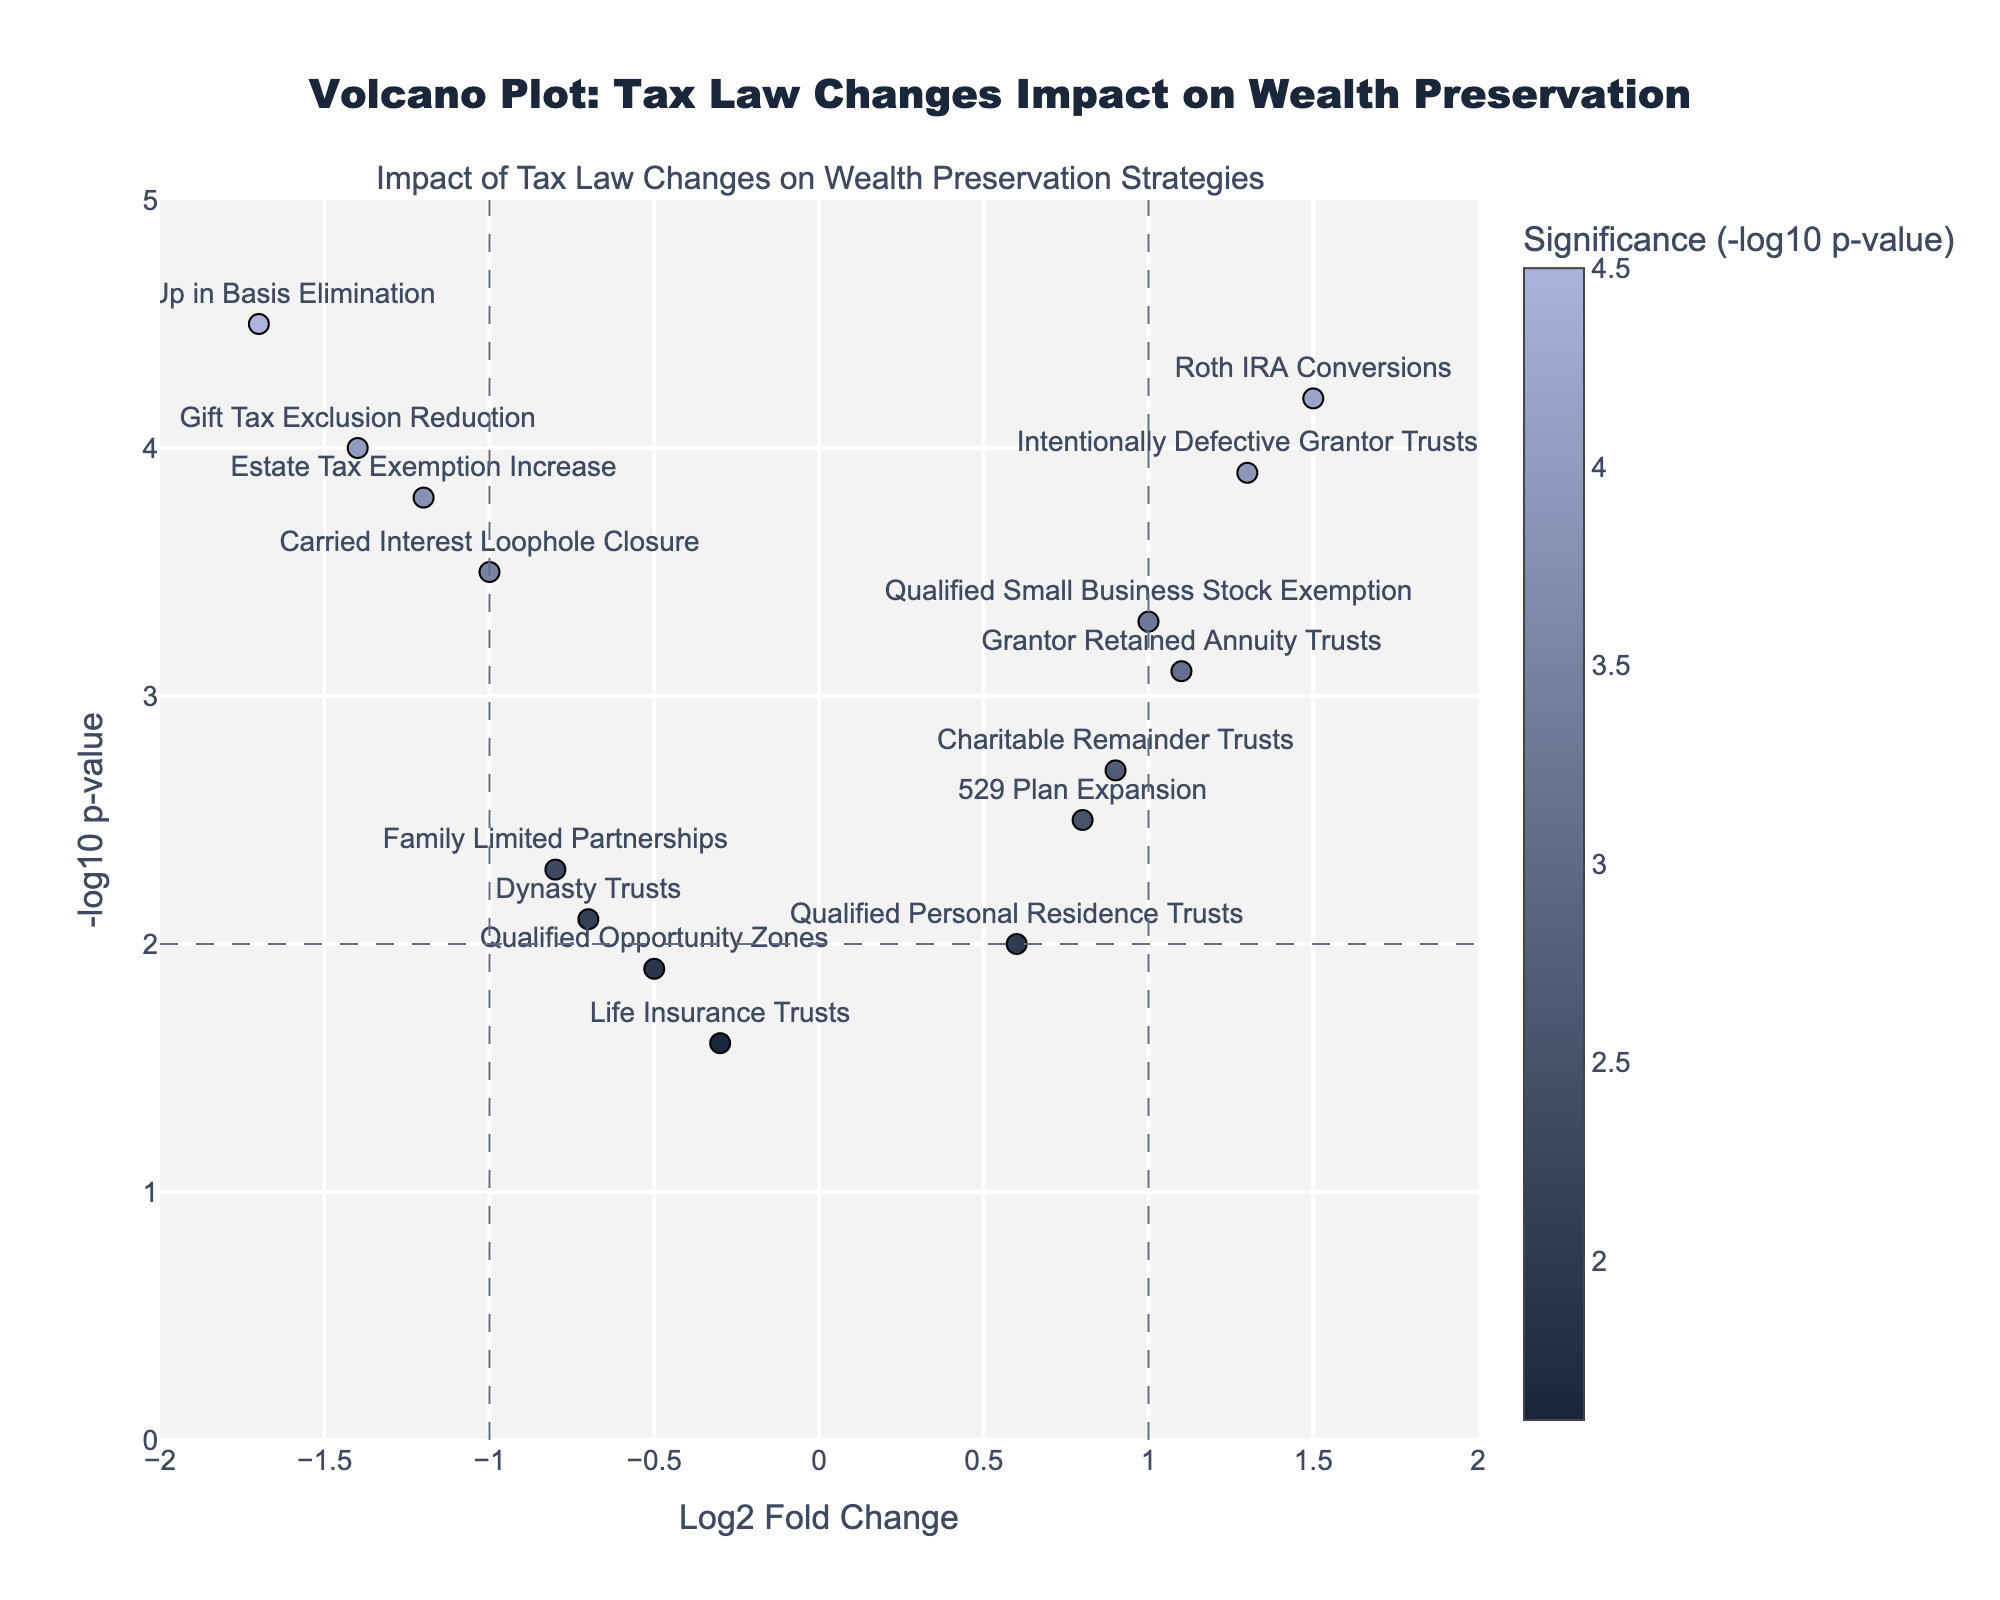What is the title of the plot? The title of the plot is located at the top center and reads: "Volcano Plot: Tax Law Changes Impact on Wealth Preservation".
Answer: "Volcano Plot: Tax Law Changes Impact on Wealth Preservation" Which strategy has the highest -log10 p-value? To find the strategy with the highest -log10 p-value, look for the point at the top of the y-axis. The strategy labeled "Step-Up in Basis Elimination" is the highest.
Answer: Step-Up in Basis Elimination How many strategies have a log2 fold change greater than 0.5 and a -log10 p-value greater than 3? Identify the points with x-coordinates greater than 0.5 and y-coordinates greater than 3. The strategies are "Roth IRA Conversions", "Intentionally Defective Grantor Trusts", and "Grantor Retained Annuity Trusts", totaling three points.
Answer: 3 Which point is closest to the origin (0,0) on the plot? The closest point to (0,0) will have the smallest combined absolute values of log2 fold change and -log10 p-value. Here, "Life Insurance Trusts" at (-0.3, 1.6) is the nearest.
Answer: Life Insurance Trusts How many strategies fall to the left of the vertical line at x = -1? Count all the points with x-coordinates less than -1. The strategies are "Step-Up in Basis Elimination", "Estate Tax Exemption Increase", and "Gift Tax Exclusion Reduction", totaling three.
Answer: 3 Which strategies are aligned vertically (same log2 fold change) in the plot? Look for points with the same x-coordinate. "Grantor Retained Annuity Trusts" and "Qualified Small Business Stock Exemption" both have a log2 fold change of 1.0.
Answer: Grantor Retained Annuity Trusts and Qualified Small Business Stock Exemption What is the range of the -log10 p-values in the plot? Identify the smallest and largest y-coordinates in the plot. The smallest is 1.6 (Life Insurance Trusts) and the largest is 4.5 (Step-Up in Basis Elimination). Therefore, the range is from 1.6 to 4.5.
Answer: 1.6 to 4.5 Which two strategies have the largest difference in their log2 fold change values? Calculate the difference between the log2 fold change values for each pair of strategies. The largest difference is between "Roth IRA Conversions" (1.5) and "Step-Up in Basis Elimination" (-1.7), which has a difference of 3.2 units.
Answer: Roth IRA Conversions and Step-Up in Basis Elimination 